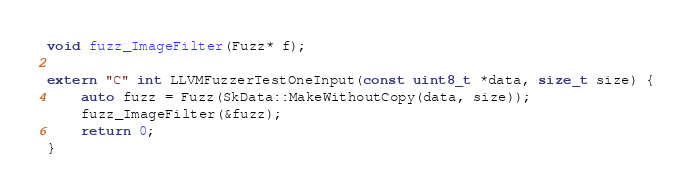<code> <loc_0><loc_0><loc_500><loc_500><_C++_>
void fuzz_ImageFilter(Fuzz* f);

extern "C" int LLVMFuzzerTestOneInput(const uint8_t *data, size_t size) {
    auto fuzz = Fuzz(SkData::MakeWithoutCopy(data, size));
    fuzz_ImageFilter(&fuzz);
    return 0;
}
</code> 